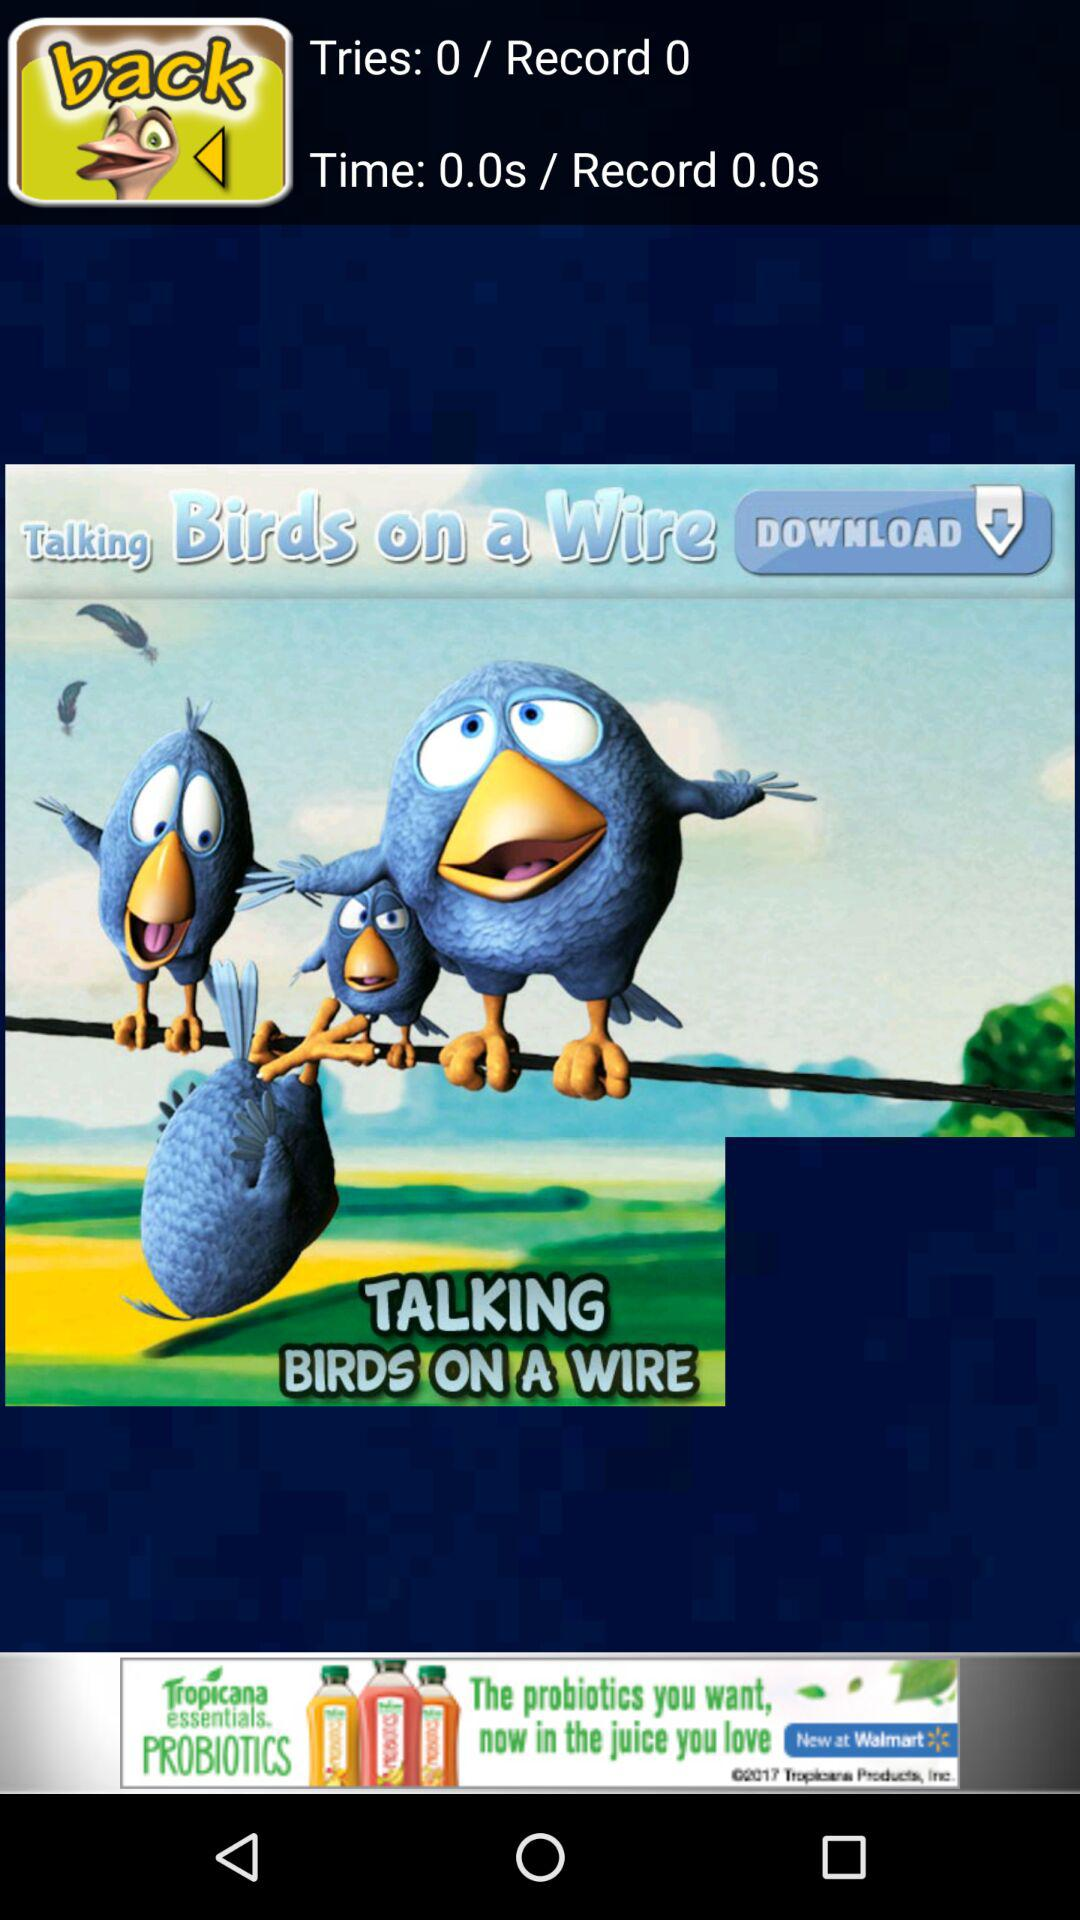How many records were there? There were 0 records. 